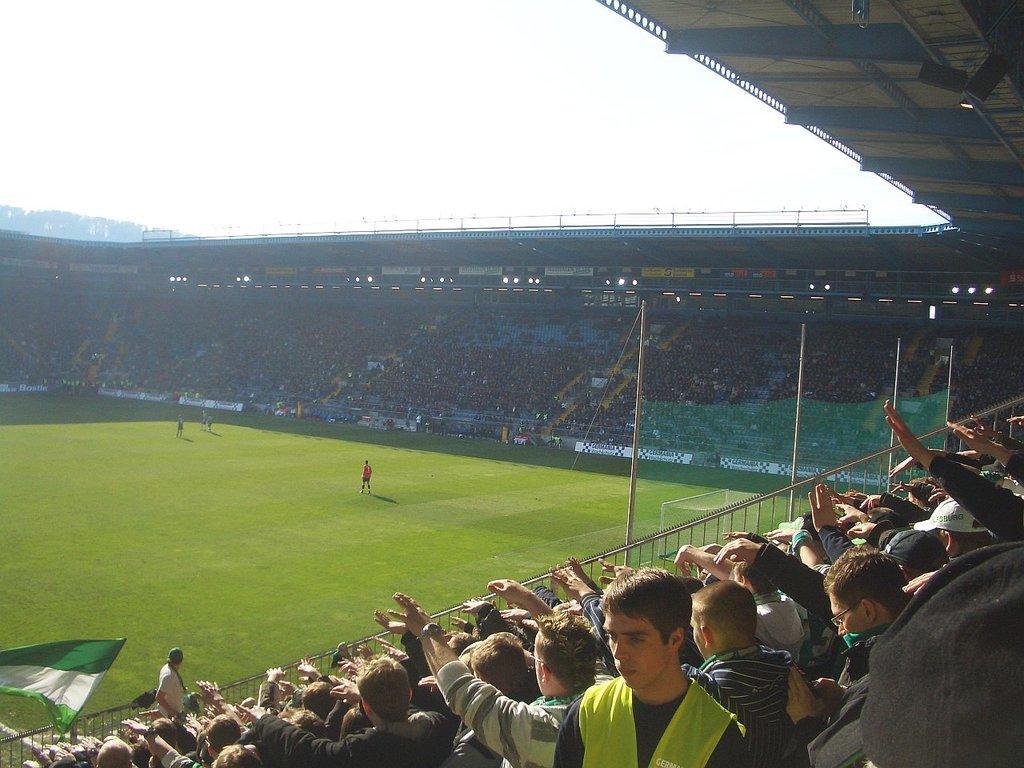Please provide a concise description of this image. In this picture we can see a group of people where some are standing on the ground, flag, poles, lights, grass and in the background we can see the sky. 